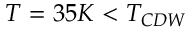Convert formula to latex. <formula><loc_0><loc_0><loc_500><loc_500>T = 3 5 K < T _ { C D W }</formula> 